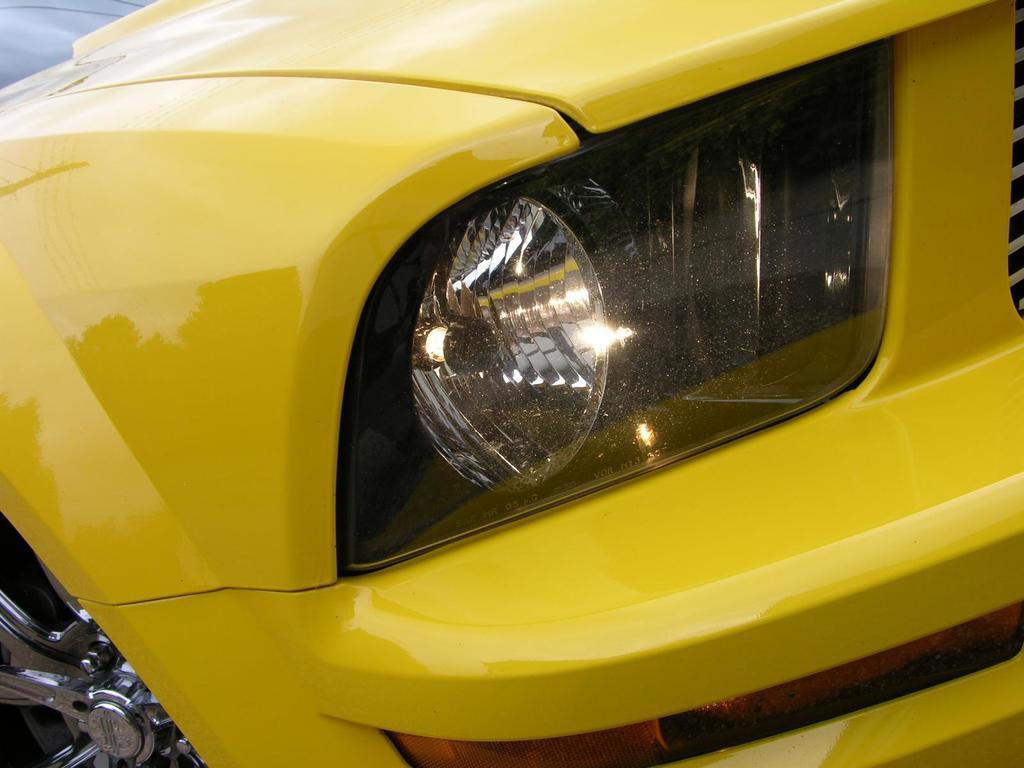Could you give a brief overview of what you see in this image? In this picture there is a yellow color car in the center of the image. 